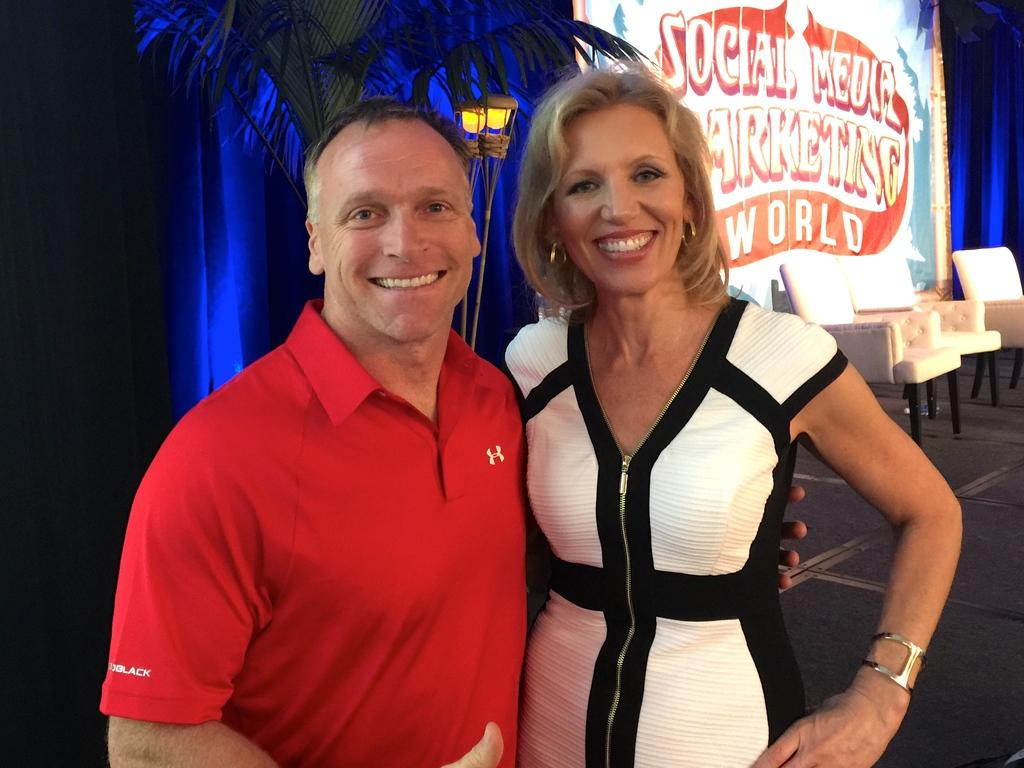What can be seen in the background of the image? In the background of the image, there is a banner, chairs, a light, and a plant. What are the people in the image doing? The woman and the man in the image are giving a pose to the camera. How are the people in the image feeling? The woman and the man in the image are smiling, which suggests they are happy or enjoying themselves. What type of fire can be seen in the image? There is no fire present in the image. How many girls are visible in the image? The image only features a woman and a man; there are no girls present. 